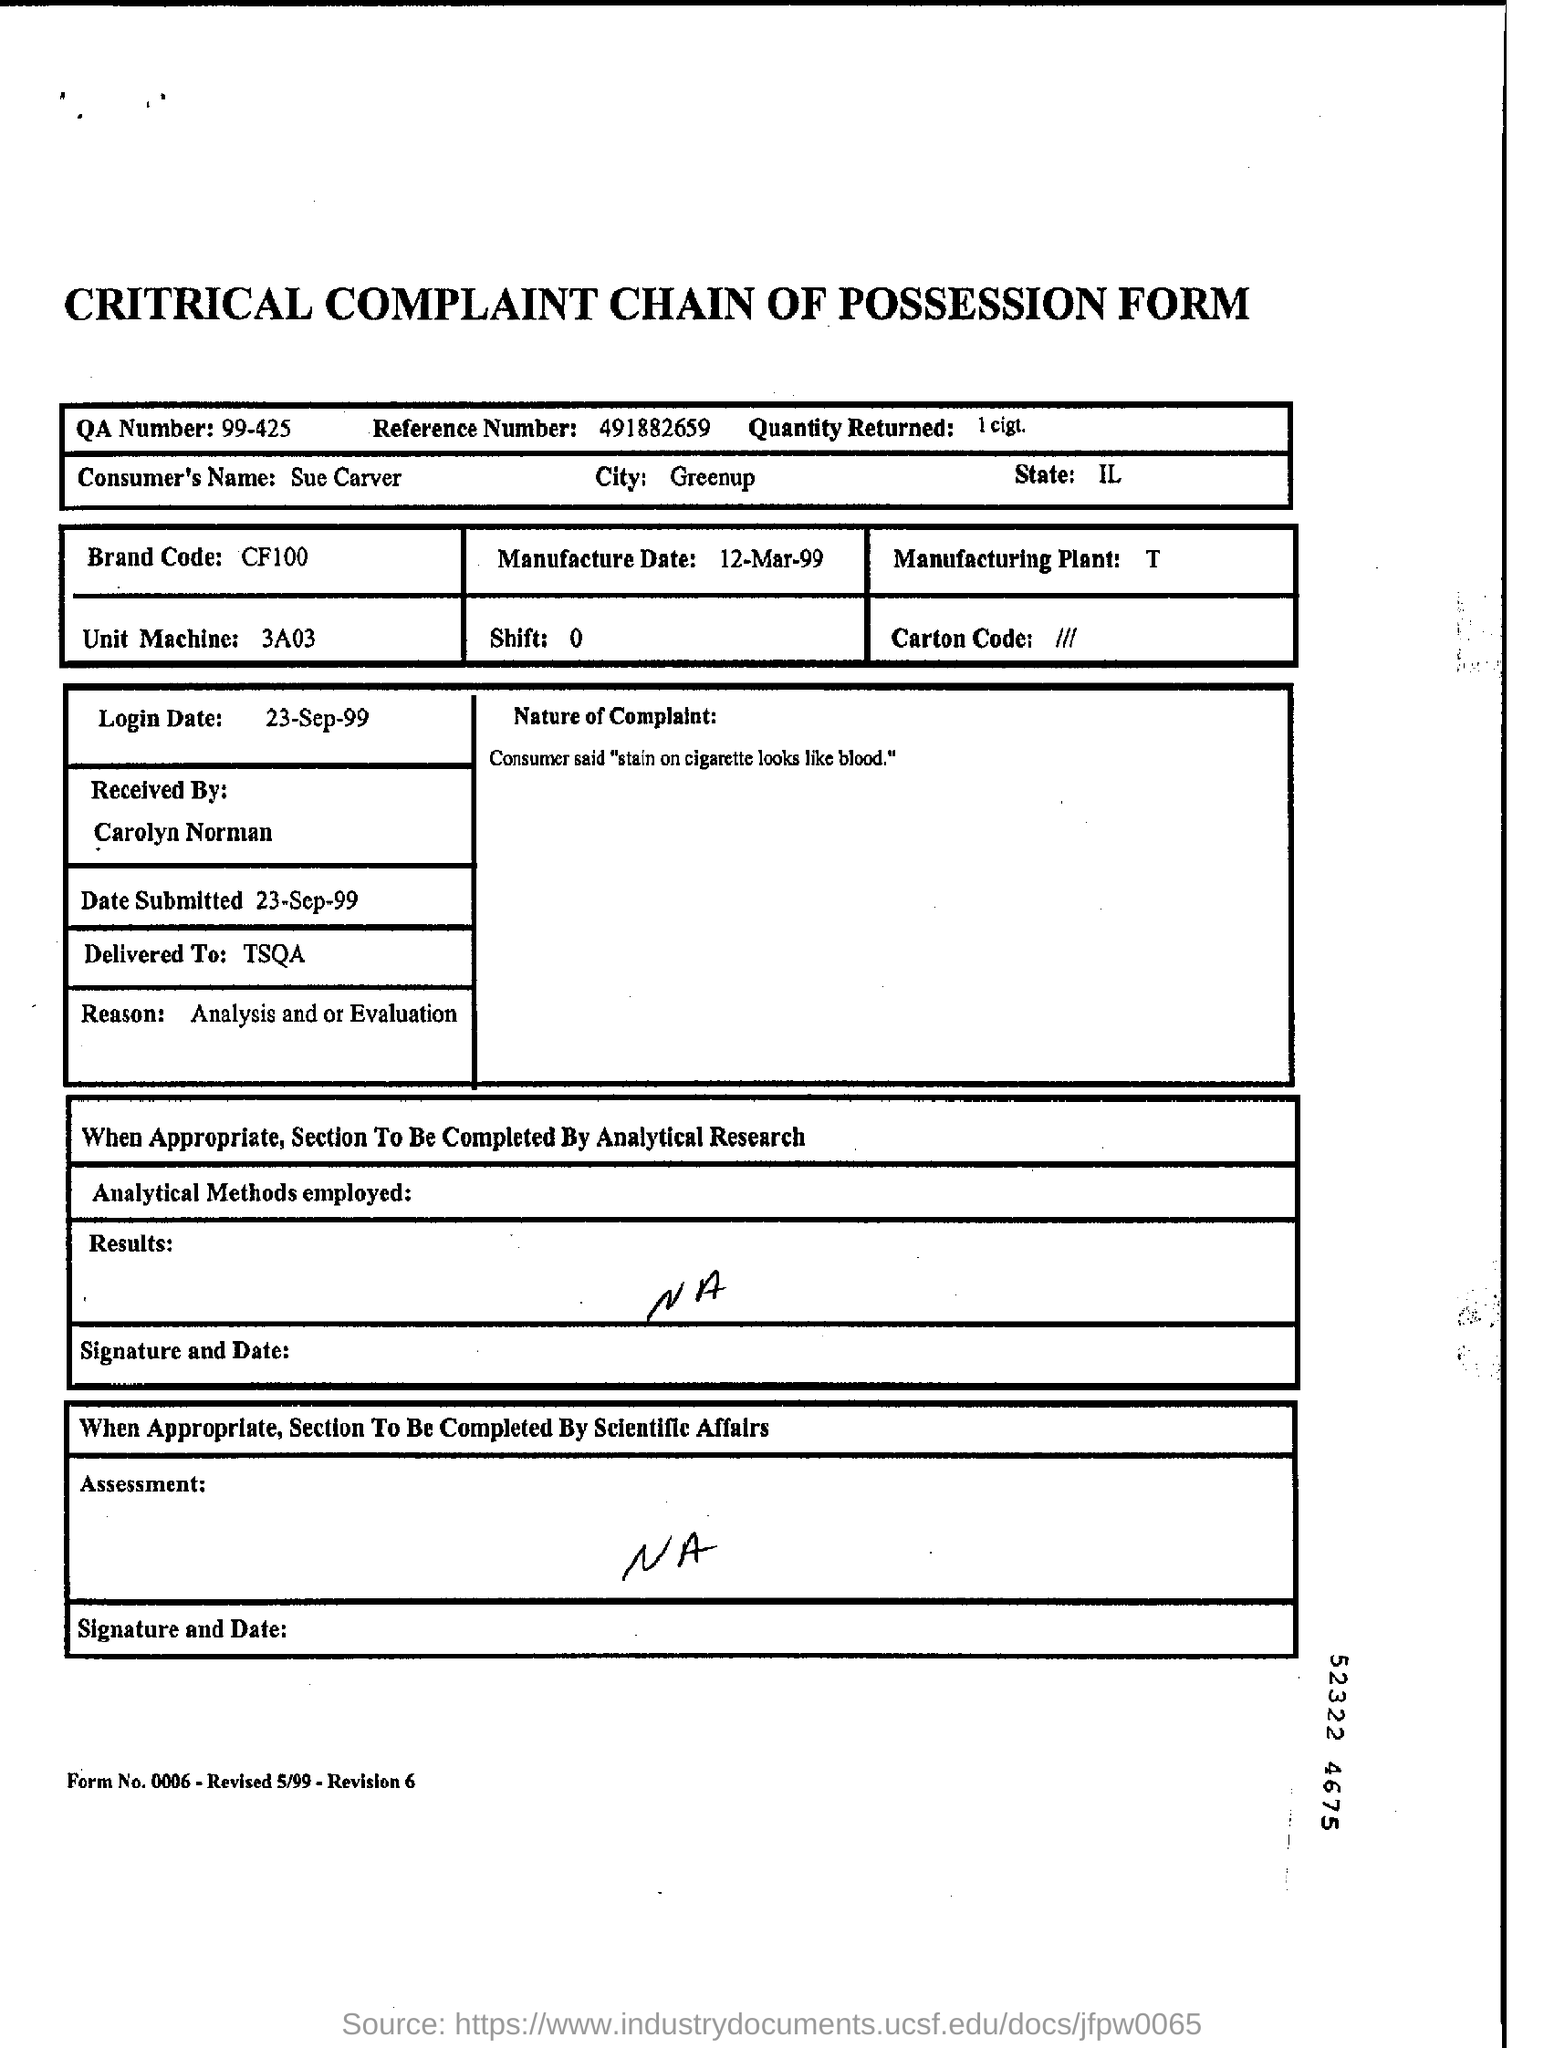Identify some key points in this picture. The login date is September 23, 1999. The city is Greenup. The Brand Code is CF100... QA Number 99-425 refers to a specific regulatory document. The quantity returned is 1 cigarette. 